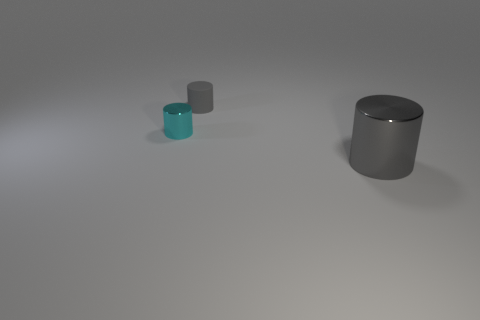Is the size of the cyan shiny thing the same as the gray object behind the big gray shiny cylinder?
Offer a very short reply. Yes. The gray thing that is in front of the tiny gray rubber object has what shape?
Provide a short and direct response. Cylinder. Is there anything else that has the same shape as the big gray object?
Your answer should be compact. Yes. Is there a gray cylinder?
Your answer should be compact. Yes. There is a gray thing that is to the left of the big gray metal object; is it the same size as the cylinder in front of the small cyan shiny object?
Offer a very short reply. No. What is the material of the thing that is both in front of the tiny rubber thing and behind the big gray object?
Your answer should be compact. Metal. There is a large cylinder; what number of gray cylinders are behind it?
Offer a terse response. 1. Is there any other thing that has the same size as the gray matte object?
Offer a terse response. Yes. The small thing that is made of the same material as the big gray cylinder is what color?
Ensure brevity in your answer.  Cyan. Does the cyan metallic object have the same shape as the big metallic object?
Make the answer very short. Yes. 